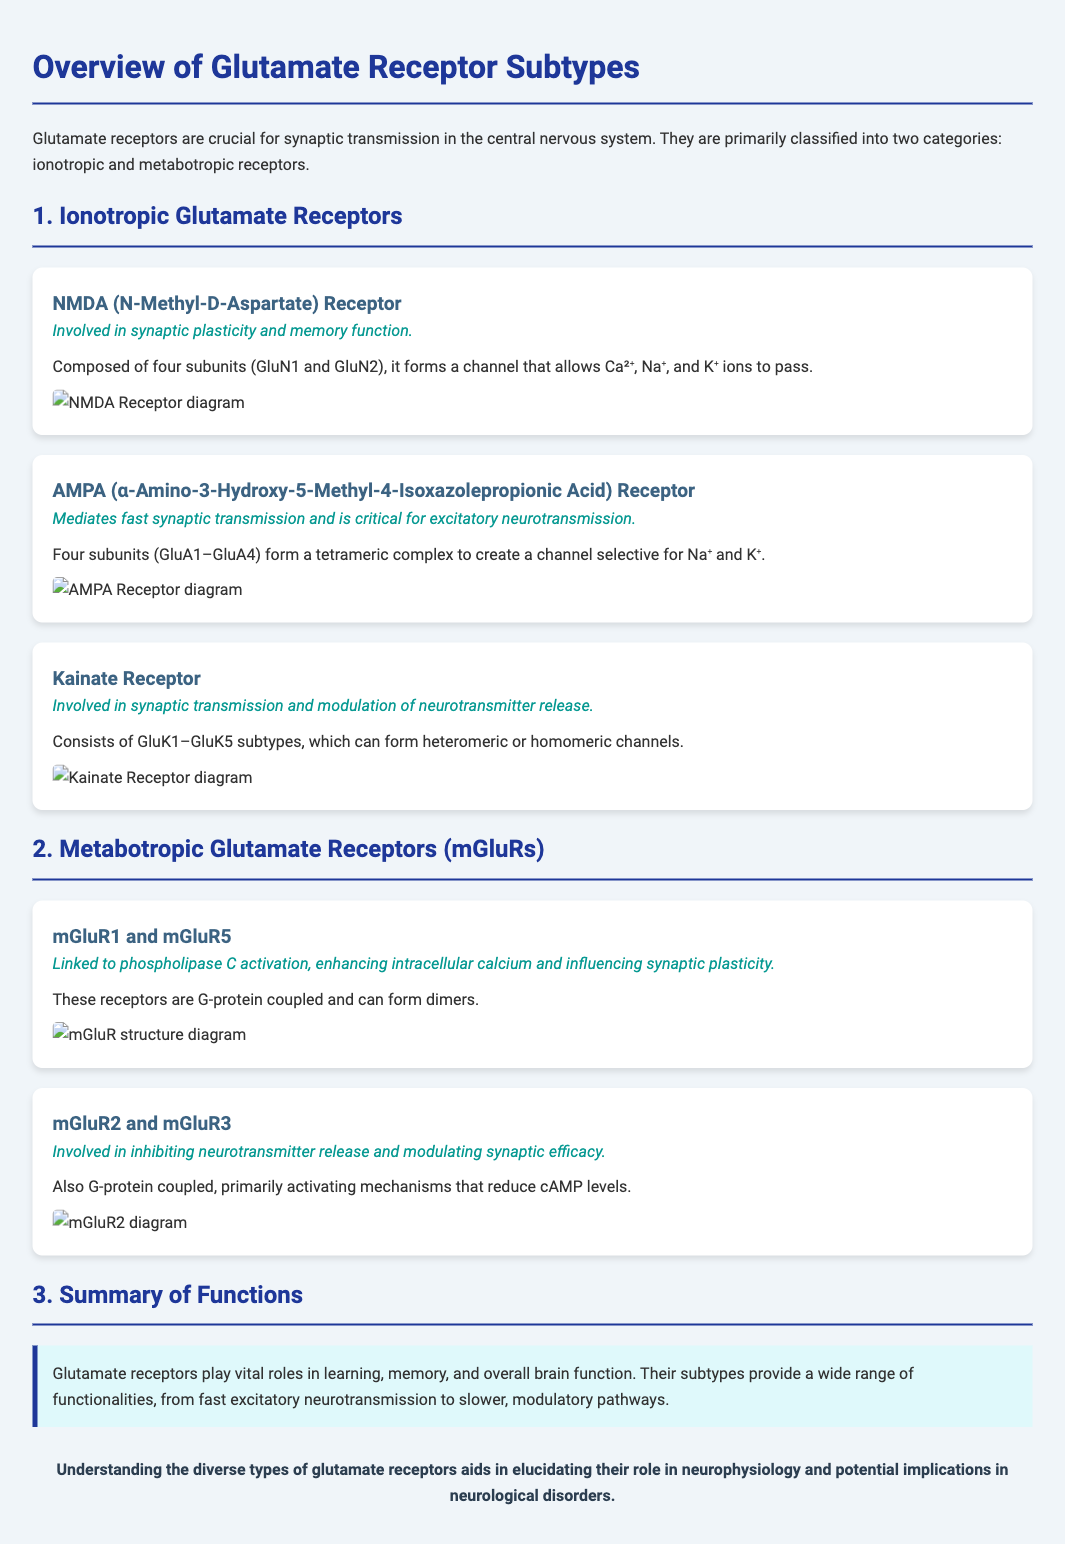What are the two categories of glutamate receptors? The document classifies glutamate receptors into two categories: ionotropic and metabotropic receptors.
Answer: Ionotropic and metabotropic How many subunits does the NMDA receptor consist of? The NMDA receptor is composed of four subunits (GluN1 and GluN2).
Answer: Four subunits What is the primary function of the AMPA receptor? The AMPA receptor mediates fast synaptic transmission and is critical for excitatory neurotransmission.
Answer: Fast synaptic transmission Which receptor is involved in synaptic plasticity and memory function? The document states that the NMDA receptor is involved in synaptic plasticity and memory function.
Answer: NMDA receptor What type of receptors are mGluR1 and mGluR5? mGluR1 and mGluR5 are described as G-protein coupled receptors.
Answer: G-protein coupled How do mGluR2 and mGluR3 primarily affect neurotransmitter release? mGluR2 and mGluR3 are involved in inhibiting neurotransmitter release.
Answer: Inhibiting neurotransmitter release What is the primary ion that AMPA receptors are selective for? The AMPA receptor creates a channel selective for Na⁺ and K⁺.
Answer: Na⁺ and K⁺ What kind of pathways do glutamate receptors influence in the brain? The summary indicates that glutamate receptors influence learning, memory, and overall brain function.
Answer: Learning and memory Which diagram represents the Kainate receptor? The Kainate receptor diagram is the one showing the structural composition of GluK1–GluK5 subtypes.
Answer: Kainate receptor diagram 